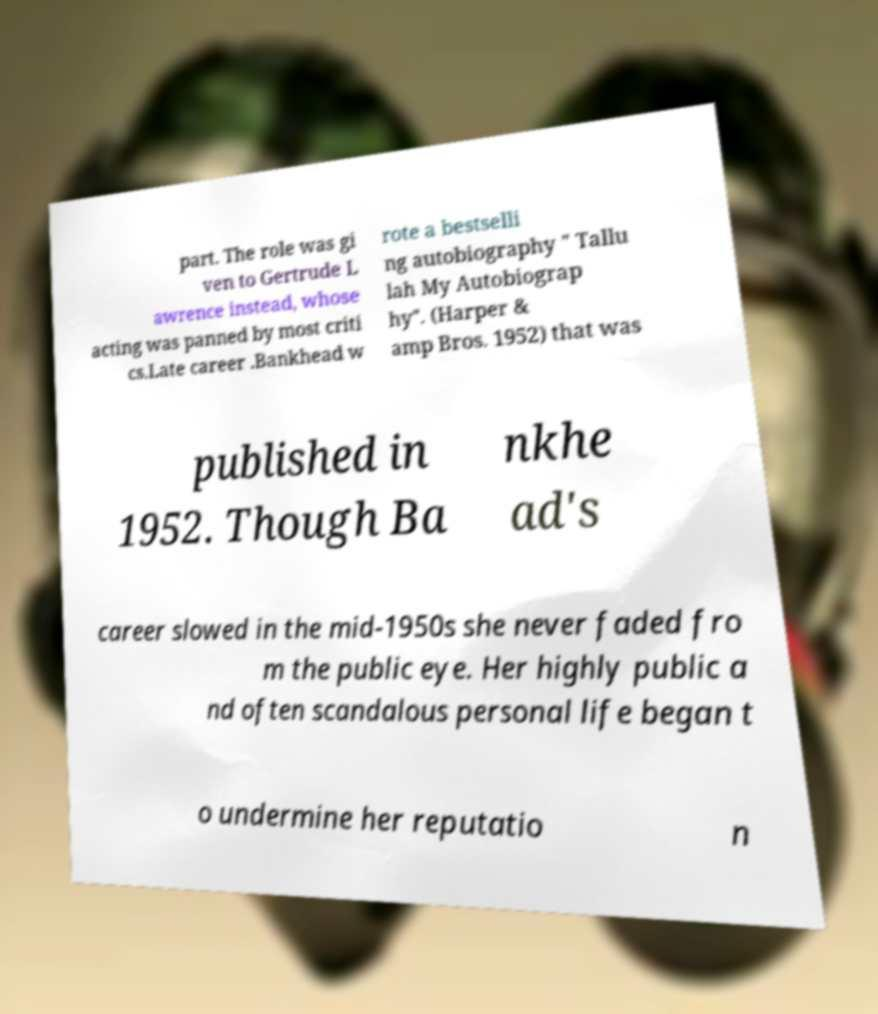What messages or text are displayed in this image? I need them in a readable, typed format. part. The role was gi ven to Gertrude L awrence instead, whose acting was panned by most criti cs.Late career .Bankhead w rote a bestselli ng autobiography " Tallu lah My Autobiograp hy". (Harper & amp Bros. 1952) that was published in 1952. Though Ba nkhe ad's career slowed in the mid-1950s she never faded fro m the public eye. Her highly public a nd often scandalous personal life began t o undermine her reputatio n 